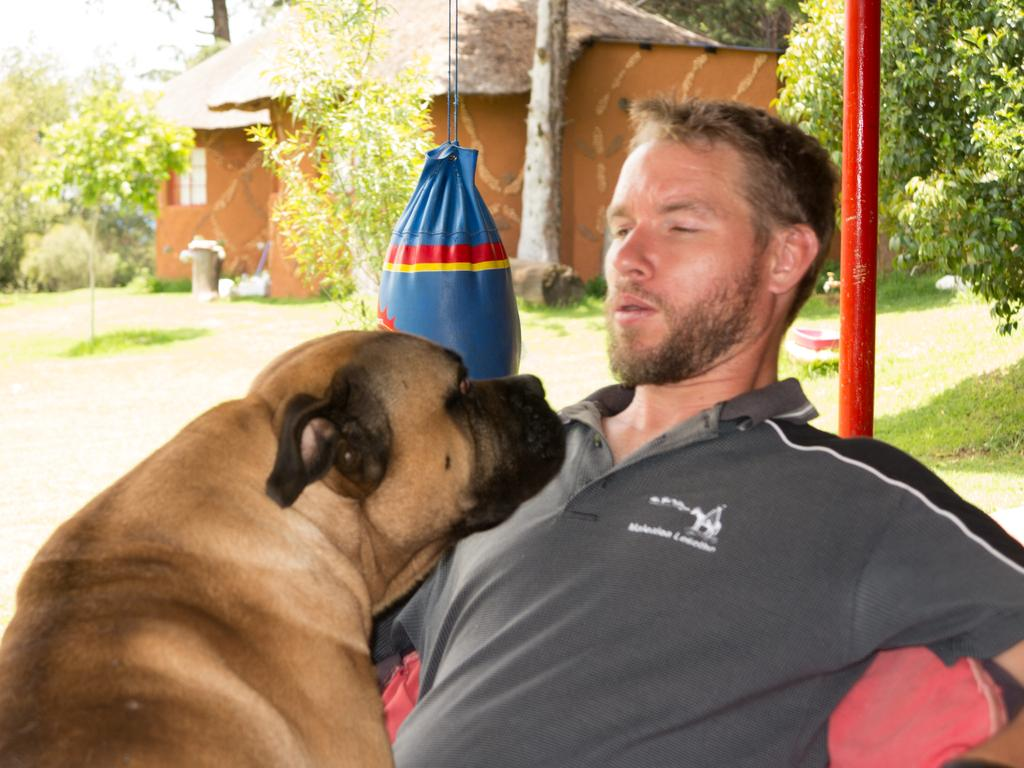What is the person in the image doing? The person is sitting on a chair in the image. What other living creature is present in the image? There is a dog in the image. What type of equipment can be seen in the image? There is a boxing bag in the image. What can be seen in the background of the image? There is a house and trees in the background of the image. What type of food is the person eating while sitting on the chair in the image? There is no food present in the image, so it cannot be determined what the person might be eating. 